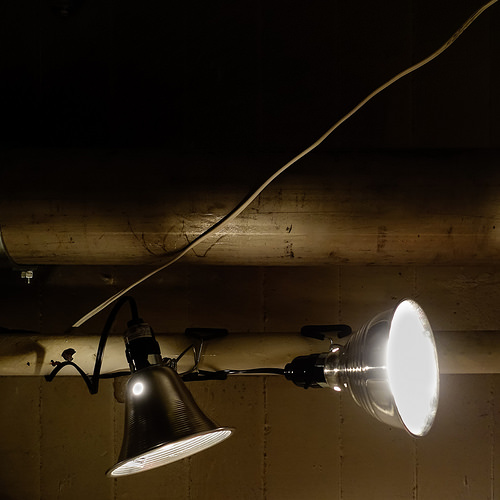<image>
Is there a light on the pole? No. The light is not positioned on the pole. They may be near each other, but the light is not supported by or resting on top of the pole. 